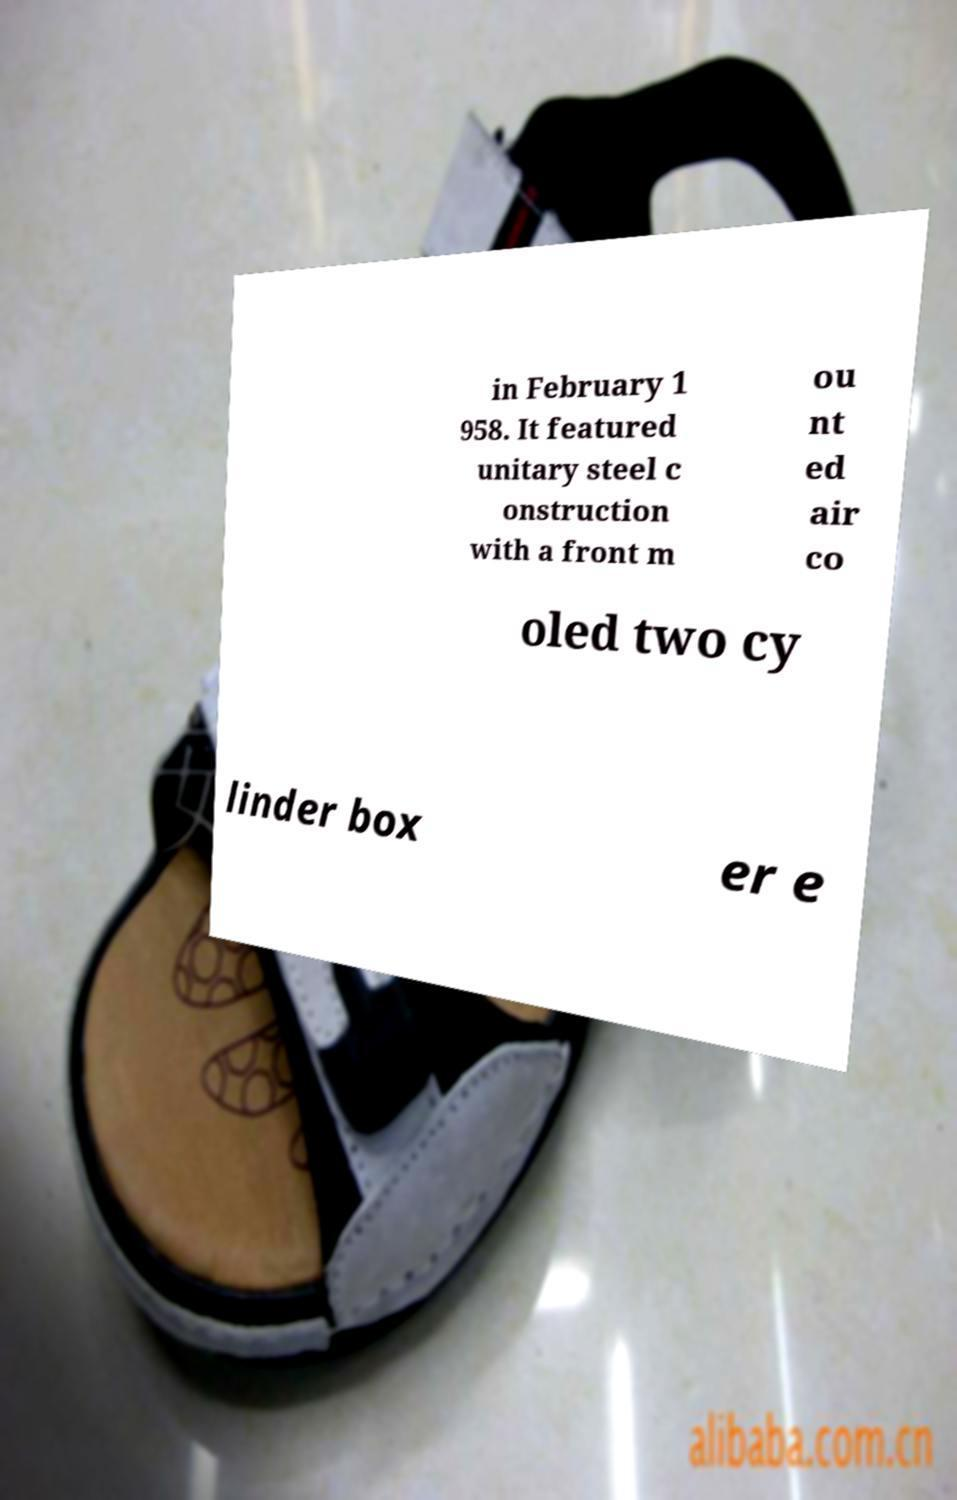I need the written content from this picture converted into text. Can you do that? in February 1 958. It featured unitary steel c onstruction with a front m ou nt ed air co oled two cy linder box er e 